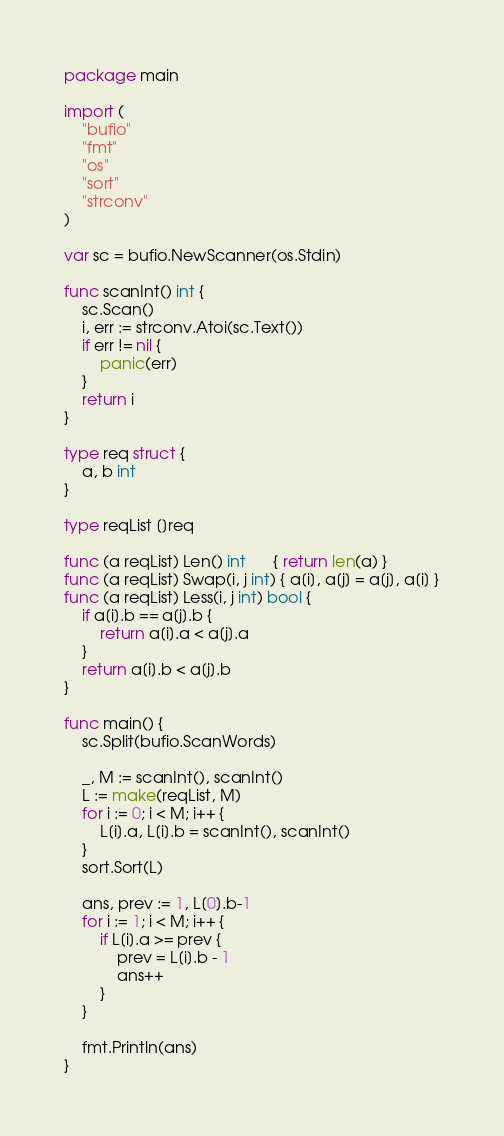Convert code to text. <code><loc_0><loc_0><loc_500><loc_500><_Go_>package main

import (
	"bufio"
	"fmt"
	"os"
	"sort"
	"strconv"
)

var sc = bufio.NewScanner(os.Stdin)

func scanInt() int {
	sc.Scan()
	i, err := strconv.Atoi(sc.Text())
	if err != nil {
		panic(err)
	}
	return i
}

type req struct {
	a, b int
}

type reqList []req

func (a reqList) Len() int      { return len(a) }
func (a reqList) Swap(i, j int) { a[i], a[j] = a[j], a[i] }
func (a reqList) Less(i, j int) bool {
	if a[i].b == a[j].b {
		return a[i].a < a[j].a
	}
	return a[i].b < a[j].b
}

func main() {
	sc.Split(bufio.ScanWords)

	_, M := scanInt(), scanInt()
	L := make(reqList, M)
	for i := 0; i < M; i++ {
		L[i].a, L[i].b = scanInt(), scanInt()
	}
	sort.Sort(L)

	ans, prev := 1, L[0].b-1
	for i := 1; i < M; i++ {
		if L[i].a >= prev {
			prev = L[i].b - 1
			ans++
		}
	}

	fmt.Println(ans)
}
</code> 